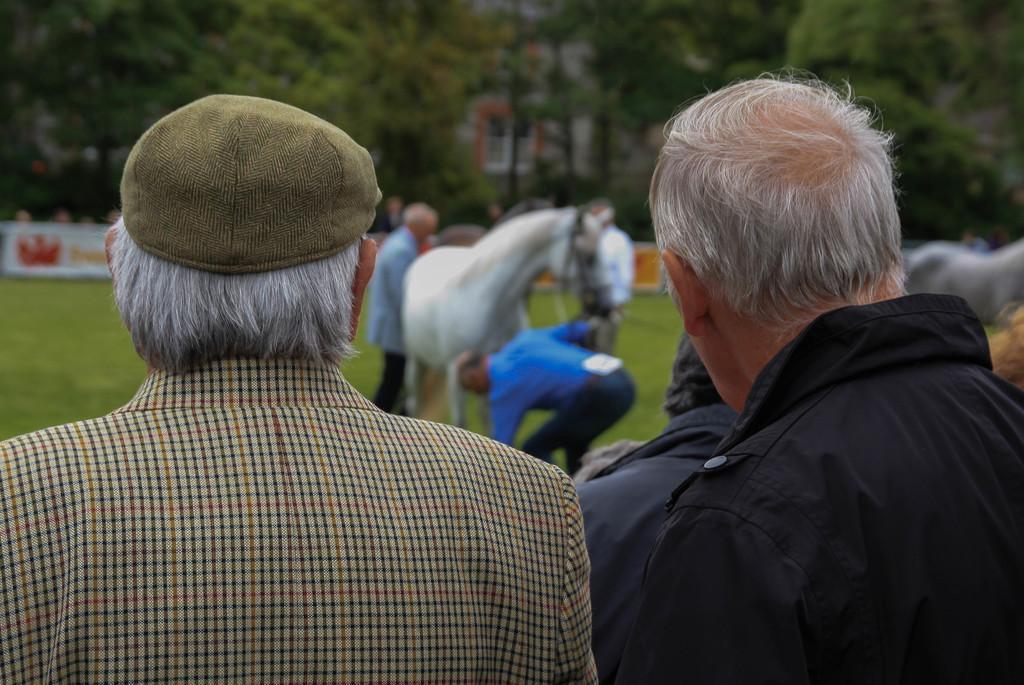Can you describe this image briefly? This picture shows people standing and a man wore cap on his head and we see couple of horses and we see trees and buildings and the grass on the ground. The horse is white in color. 